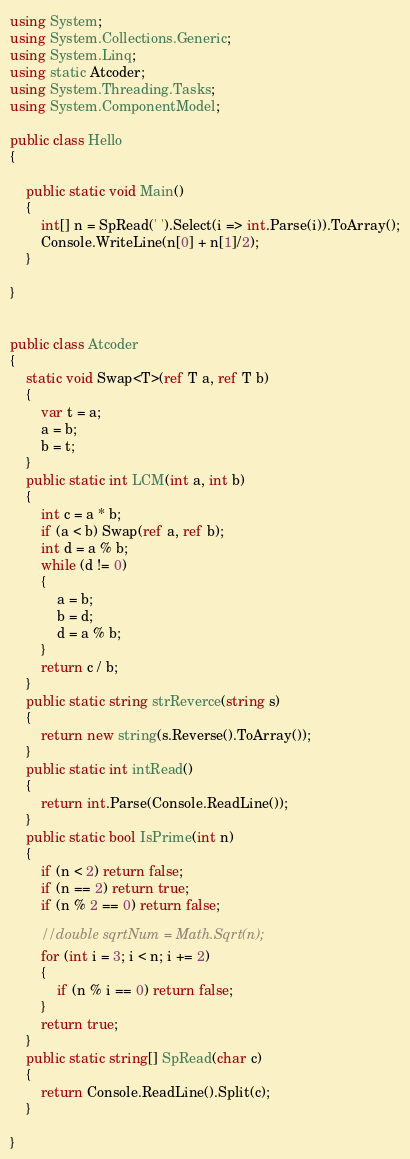<code> <loc_0><loc_0><loc_500><loc_500><_C#_>using System;
using System.Collections.Generic;
using System.Linq;
using static Atcoder;
using System.Threading.Tasks;
using System.ComponentModel;

public class Hello
{

    public static void Main()
    {
        int[] n = SpRead(' ').Select(i => int.Parse(i)).ToArray();
        Console.WriteLine(n[0] + n[1]/2);
    }

}


public class Atcoder
{
    static void Swap<T>(ref T a, ref T b)
    {
        var t = a;
        a = b;
        b = t;
    }
    public static int LCM(int a, int b)
    {
        int c = a * b;
        if (a < b) Swap(ref a, ref b);
        int d = a % b;
        while (d != 0)
        {
            a = b;
            b = d;
            d = a % b;
        }
        return c / b;
    }
    public static string strReverce(string s)
    {
        return new string(s.Reverse().ToArray());
    }
    public static int intRead()
    {
        return int.Parse(Console.ReadLine());
    }
    public static bool IsPrime(int n)
    {
        if (n < 2) return false;
        if (n == 2) return true;
        if (n % 2 == 0) return false;

        //double sqrtNum = Math.Sqrt(n);
        for (int i = 3; i < n; i += 2)
        {
            if (n % i == 0) return false;
        }
        return true;
    }
    public static string[] SpRead(char c)
    {
        return Console.ReadLine().Split(c);
    }

}
</code> 